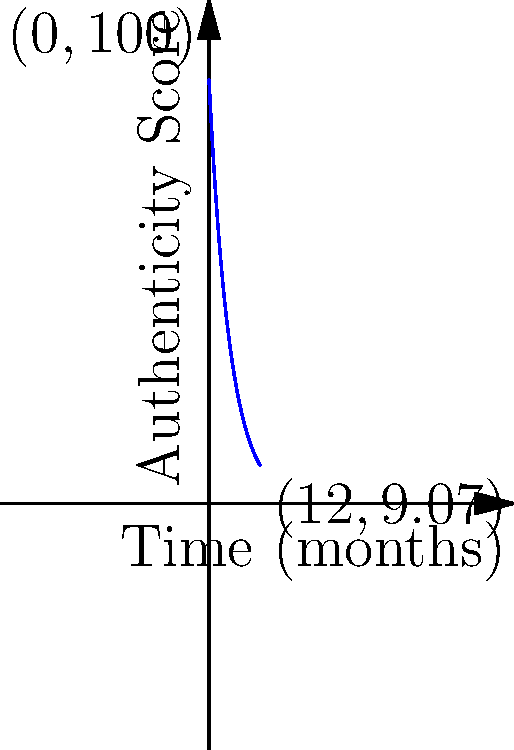The graph shows the exponential decay of an influencer's authenticity score over time. If the initial authenticity score was 100 and after 12 months it decreased to approximately 9.07, what is the monthly decay rate of the influencer's authenticity? Express your answer as a percentage rounded to two decimal places. To solve this problem, we'll use the exponential decay formula:

$A(t) = A_0 \cdot e^{-rt}$

Where:
$A(t)$ is the authenticity score at time $t$
$A_0$ is the initial authenticity score
$r$ is the decay rate
$t$ is the time in months

We know:
$A_0 = 100$
$A(12) \approx 9.07$
$t = 12$ months

Let's plug these values into the formula:

$9.07 = 100 \cdot e^{-12r}$

Dividing both sides by 100:

$0.0907 = e^{-12r}$

Taking the natural log of both sides:

$\ln(0.0907) = -12r$

$-2.4001 = -12r$

Solving for $r$:

$r = \frac{2.4001}{12} = 0.2000$

To convert this to a percentage, we multiply by 100:

$0.2000 \cdot 100 = 20.00\%$

Therefore, the monthly decay rate is approximately 20.00%.
Answer: 20.00% 